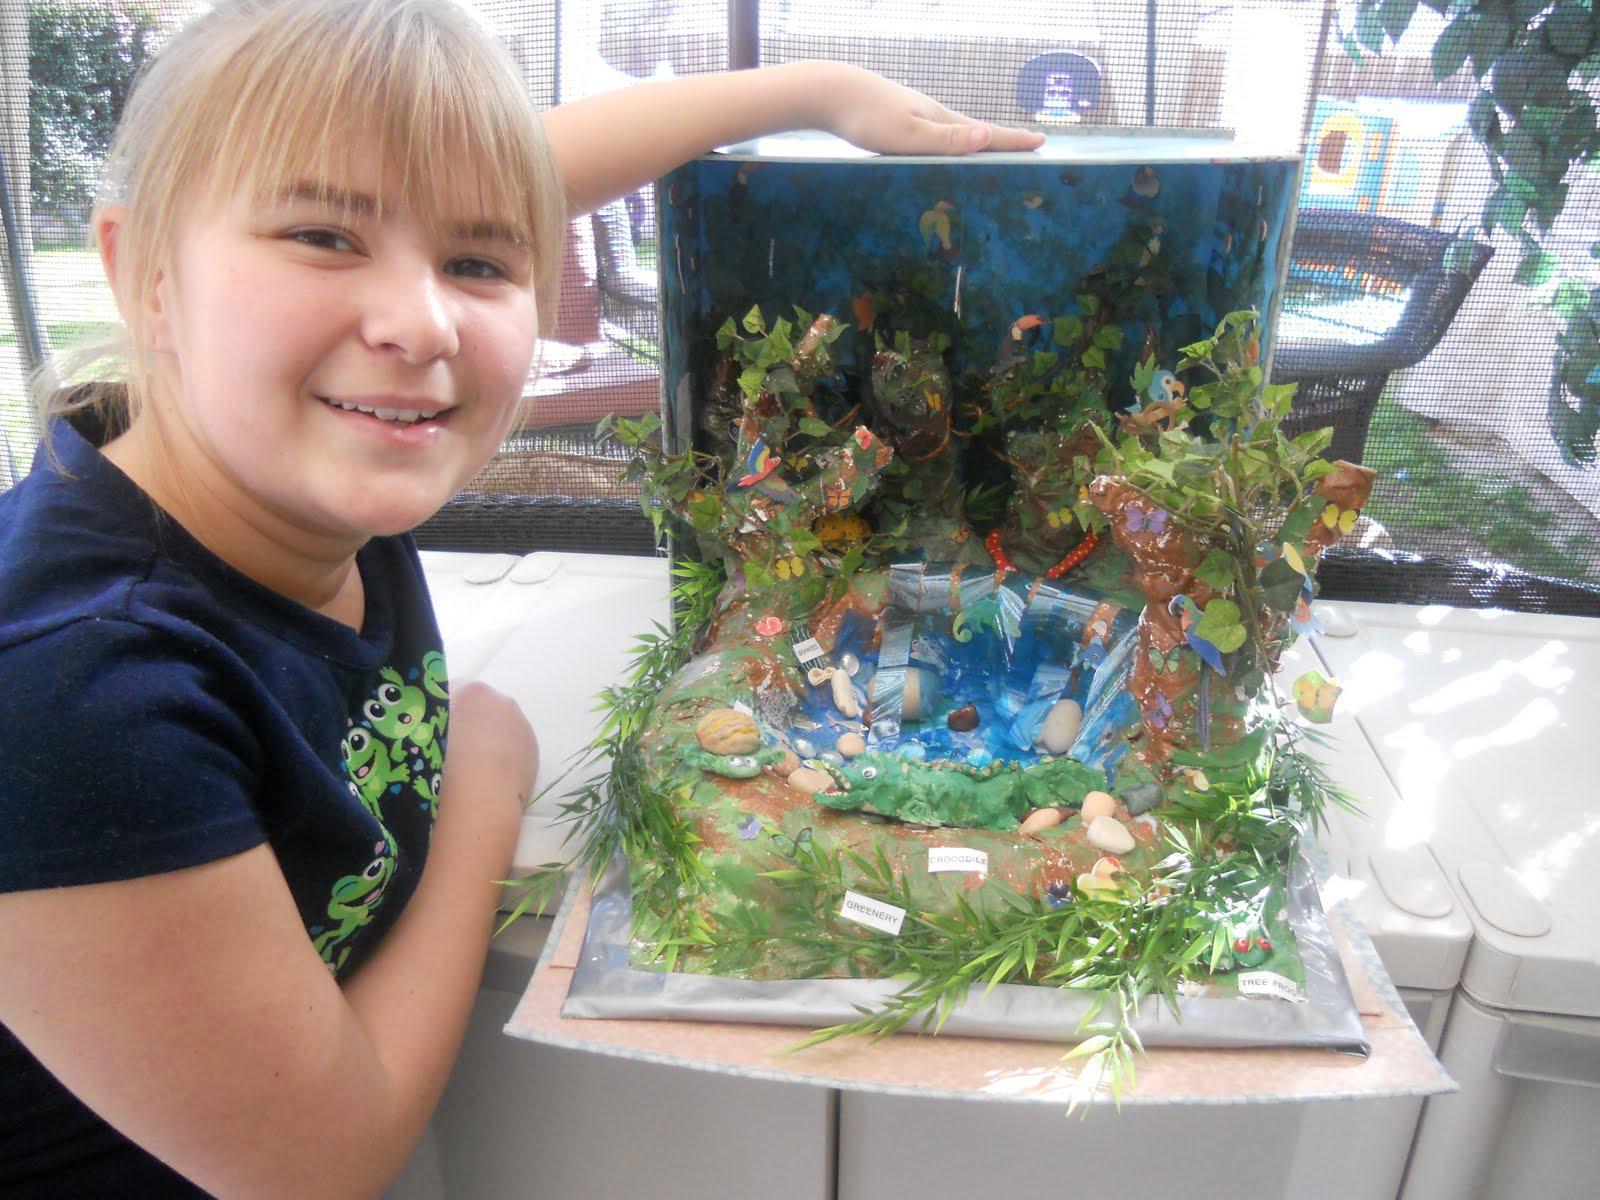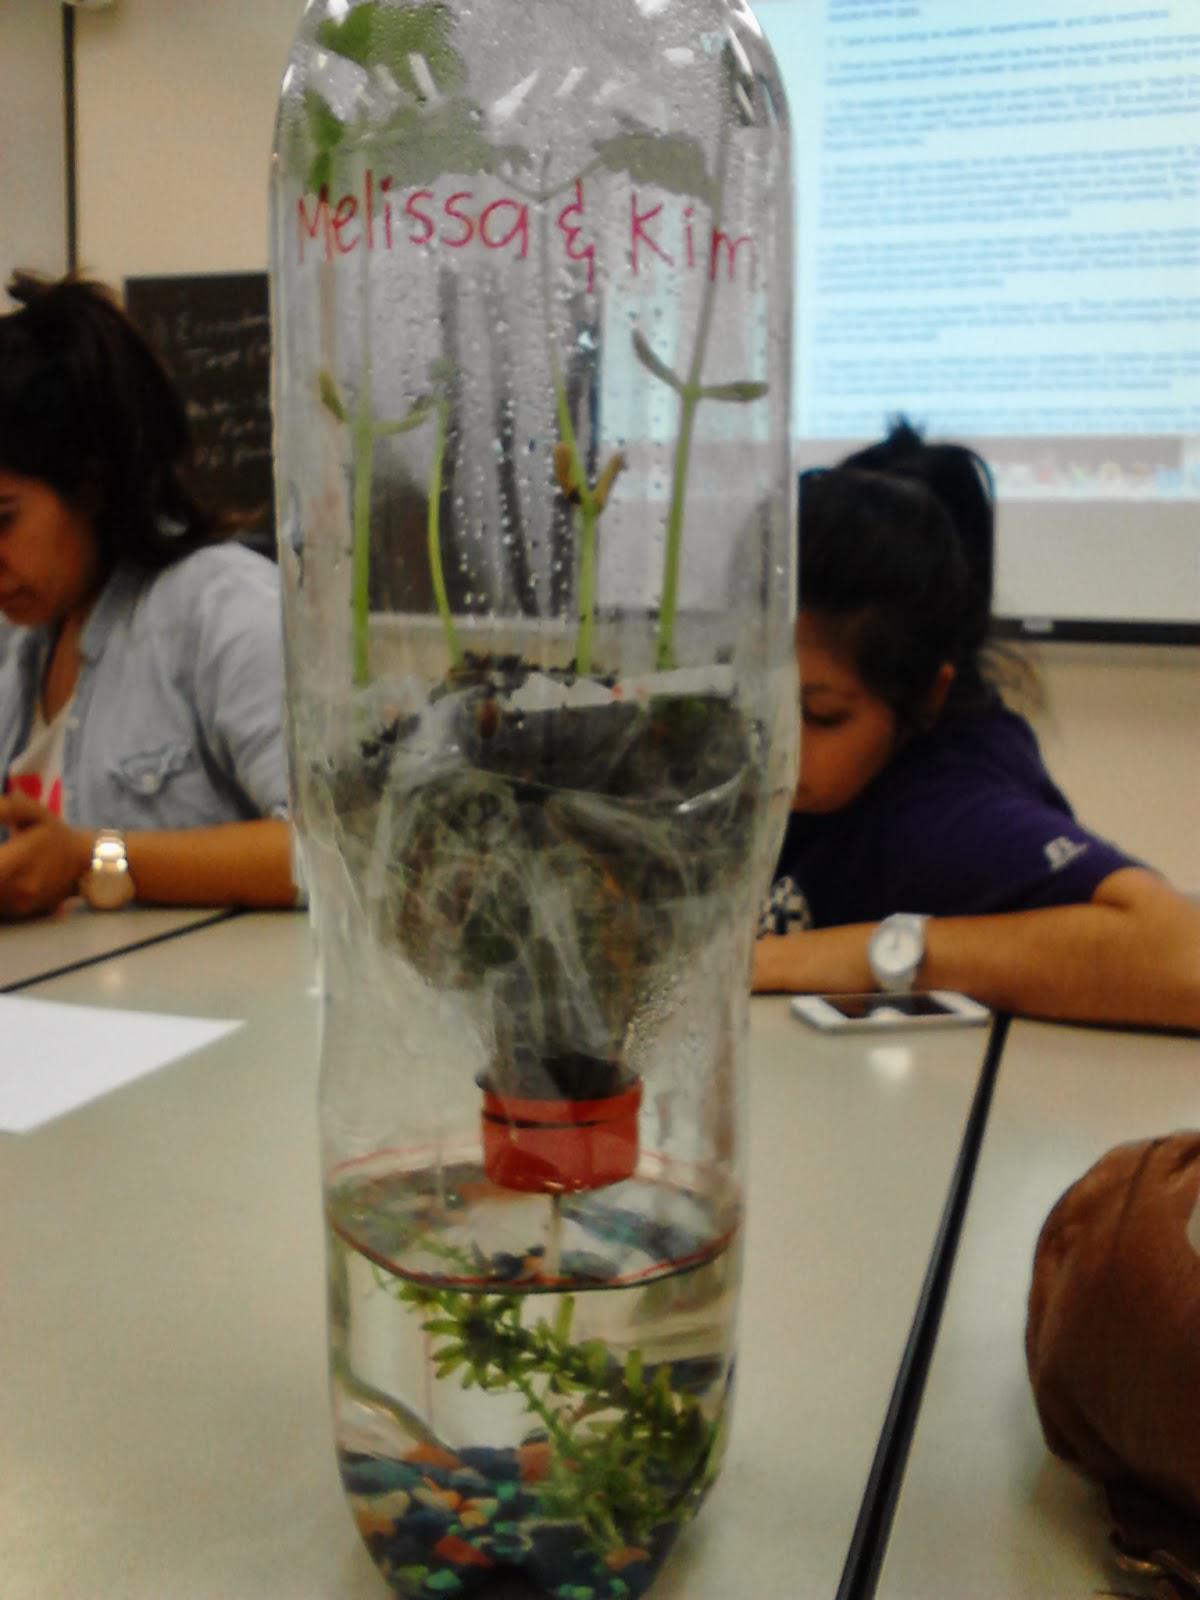The first image is the image on the left, the second image is the image on the right. For the images shown, is this caption "In one image a boy in a uniform is holding up a green plant in front of him with both hands." true? Answer yes or no. No. The first image is the image on the left, the second image is the image on the right. Assess this claim about the two images: "One person is holding a plant.". Correct or not? Answer yes or no. No. 